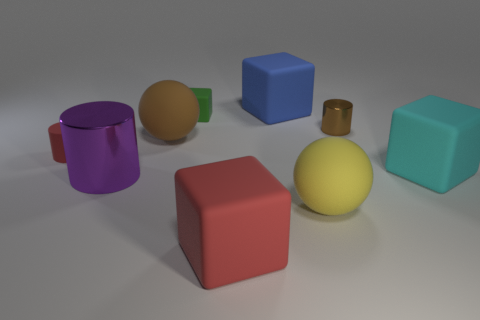How many other things are the same shape as the big brown thing?
Ensure brevity in your answer.  1. The other rubber sphere that is the same size as the brown sphere is what color?
Keep it short and to the point. Yellow. What color is the small cylinder left of the big red rubber object?
Your response must be concise. Red. There is a cylinder that is in front of the large cyan cube; is there a cyan cube in front of it?
Offer a very short reply. No. There is a large blue rubber thing; does it have the same shape as the shiny object to the left of the big red cube?
Your answer should be compact. No. There is a rubber thing that is both in front of the purple thing and to the right of the large blue object; what is its size?
Ensure brevity in your answer.  Large. Is there a large blue block that has the same material as the large cylinder?
Make the answer very short. No. The matte ball that is the same color as the small metal cylinder is what size?
Give a very brief answer. Large. What is the material of the large sphere that is to the right of the big object behind the brown shiny thing?
Offer a very short reply. Rubber. What number of tiny blocks are the same color as the tiny metal thing?
Offer a terse response. 0. 